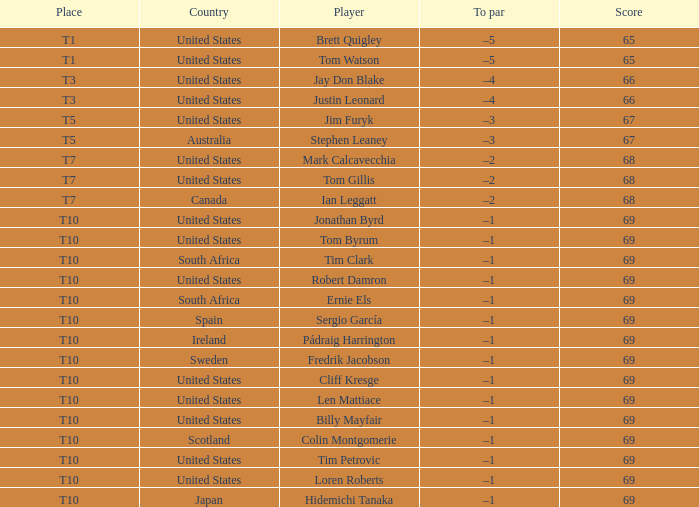What is the average score for the player who is T5 in the United States? 67.0. 